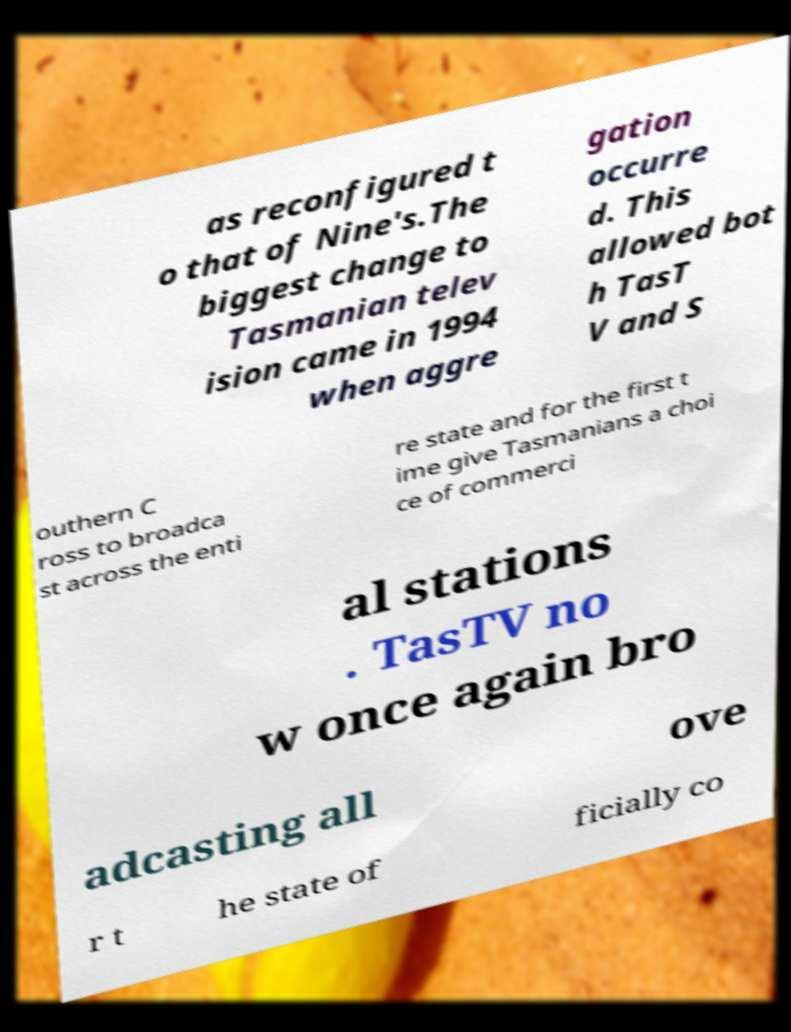Can you accurately transcribe the text from the provided image for me? as reconfigured t o that of Nine's.The biggest change to Tasmanian telev ision came in 1994 when aggre gation occurre d. This allowed bot h TasT V and S outhern C ross to broadca st across the enti re state and for the first t ime give Tasmanians a choi ce of commerci al stations . TasTV no w once again bro adcasting all ove r t he state of ficially co 